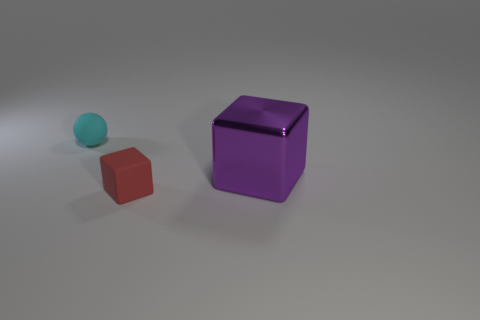What could be the purpose of this image? Is it for a product, educational use, or something else? This image seems to serve as a simple demonstration of 3D modeling, likely for educational or illustrative purposes, showcasing different shapes and colors with a focus on geometry and shading. 